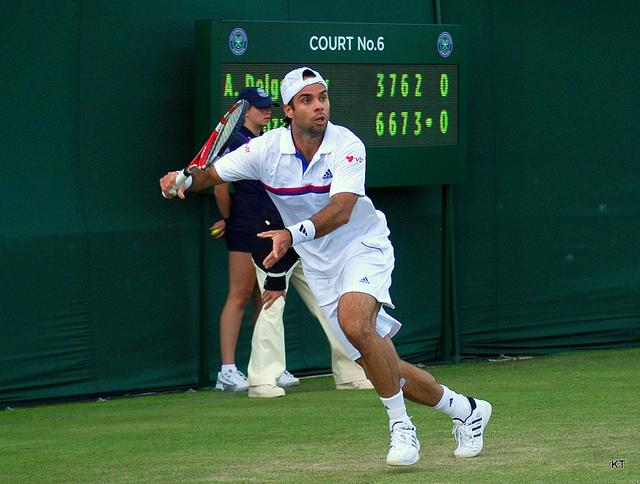What court number is the man playing on?
Be succinct. 6. What is the facial expression of the man?
Be succinct. Surprise. Is one of the players wearing green shorts?
Give a very brief answer. No. Is the person about to fall over?
Short answer required. No. What sport are they playing?
Write a very short answer. Tennis. Are there flowers in the background?
Concise answer only. No. 